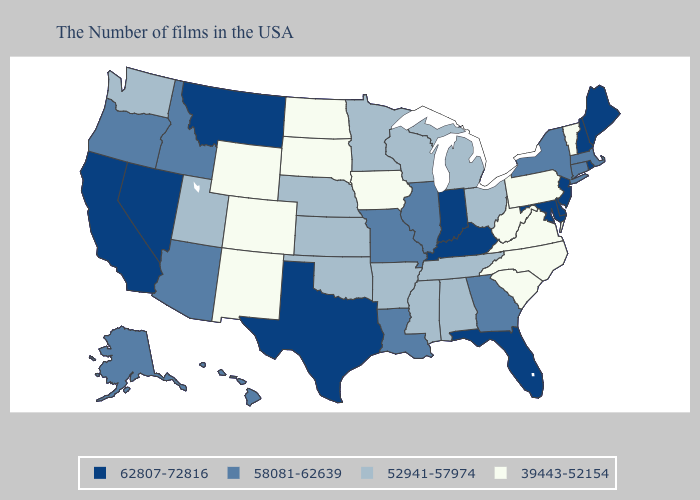Does Texas have the lowest value in the South?
Quick response, please. No. Which states have the lowest value in the USA?
Short answer required. Vermont, Pennsylvania, Virginia, North Carolina, South Carolina, West Virginia, Iowa, South Dakota, North Dakota, Wyoming, Colorado, New Mexico. Which states have the highest value in the USA?
Short answer required. Maine, Rhode Island, New Hampshire, New Jersey, Delaware, Maryland, Florida, Kentucky, Indiana, Texas, Montana, Nevada, California. Among the states that border Montana , which have the lowest value?
Quick response, please. South Dakota, North Dakota, Wyoming. What is the highest value in states that border North Dakota?
Be succinct. 62807-72816. Does Pennsylvania have the lowest value in the USA?
Keep it brief. Yes. Does Hawaii have the lowest value in the West?
Write a very short answer. No. Does Utah have a higher value than Mississippi?
Keep it brief. No. Which states have the lowest value in the USA?
Keep it brief. Vermont, Pennsylvania, Virginia, North Carolina, South Carolina, West Virginia, Iowa, South Dakota, North Dakota, Wyoming, Colorado, New Mexico. What is the value of Washington?
Write a very short answer. 52941-57974. Name the states that have a value in the range 58081-62639?
Write a very short answer. Massachusetts, Connecticut, New York, Georgia, Illinois, Louisiana, Missouri, Arizona, Idaho, Oregon, Alaska, Hawaii. What is the value of Virginia?
Be succinct. 39443-52154. What is the highest value in the West ?
Short answer required. 62807-72816. Is the legend a continuous bar?
Answer briefly. No. Does North Carolina have the lowest value in the USA?
Write a very short answer. Yes. 